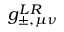Convert formula to latex. <formula><loc_0><loc_0><loc_500><loc_500>g _ { \pm , \mu \nu } ^ { L R }</formula> 